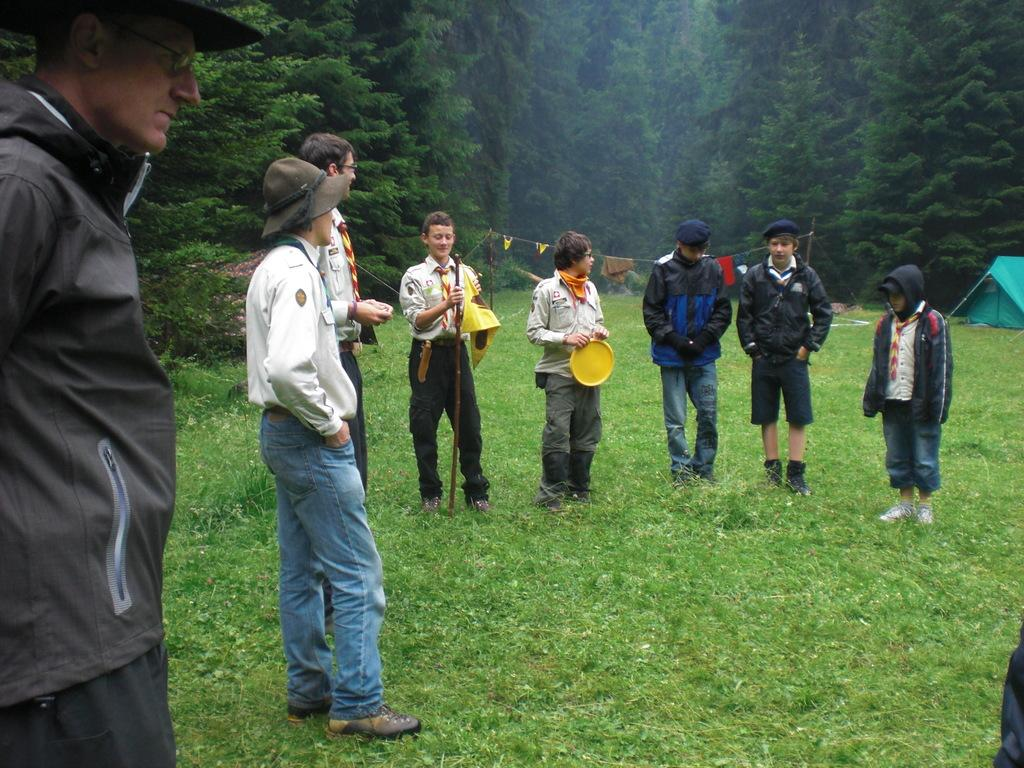What type of ground surface is visible in the image? There is green grass on the ground in the image. What can be seen in terms of human presence in the image? There are people standing in the image. What type of vegetation is visible in the background of the image? There are green color trees in the background of the image. What type of pizzas are being served to the snails in the image? There are no snails or pizzas present in the image. How many balls are visible in the image? There are no balls visible in the image. 